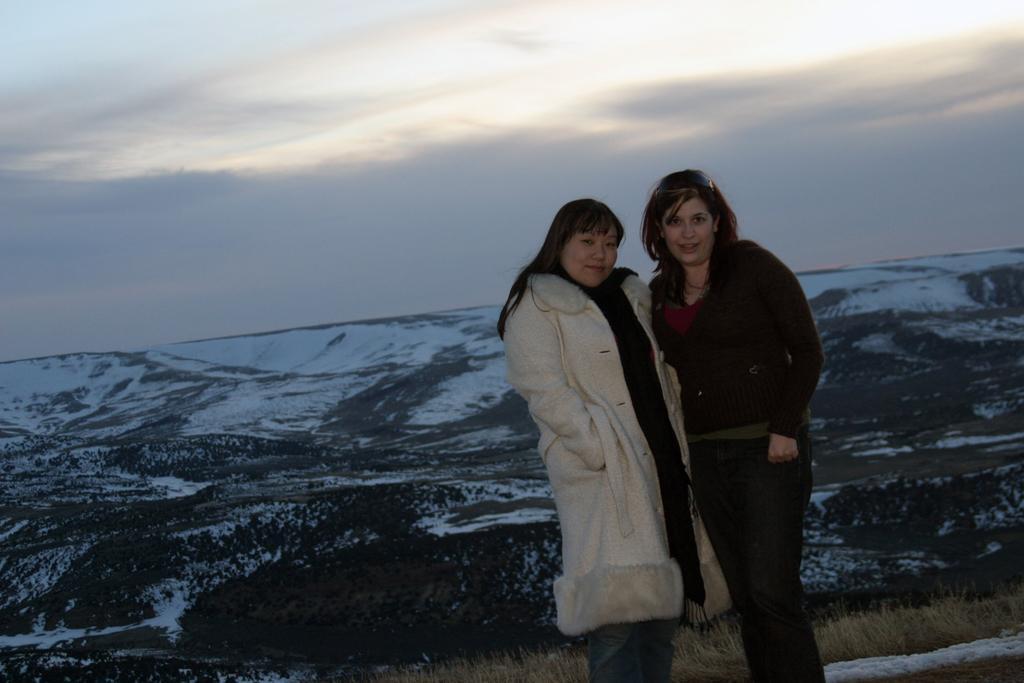How would you summarize this image in a sentence or two? There are two women standing and smiling. I think this is a snowy mountain. This looks like a dried grass. Here is the sky. 